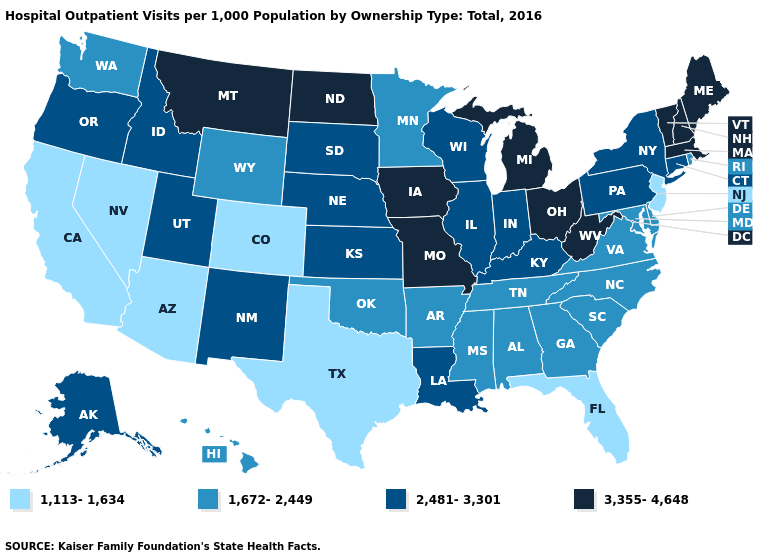Name the states that have a value in the range 2,481-3,301?
Answer briefly. Alaska, Connecticut, Idaho, Illinois, Indiana, Kansas, Kentucky, Louisiana, Nebraska, New Mexico, New York, Oregon, Pennsylvania, South Dakota, Utah, Wisconsin. What is the value of New Jersey?
Give a very brief answer. 1,113-1,634. Name the states that have a value in the range 2,481-3,301?
Keep it brief. Alaska, Connecticut, Idaho, Illinois, Indiana, Kansas, Kentucky, Louisiana, Nebraska, New Mexico, New York, Oregon, Pennsylvania, South Dakota, Utah, Wisconsin. Does the map have missing data?
Answer briefly. No. Name the states that have a value in the range 2,481-3,301?
Answer briefly. Alaska, Connecticut, Idaho, Illinois, Indiana, Kansas, Kentucky, Louisiana, Nebraska, New Mexico, New York, Oregon, Pennsylvania, South Dakota, Utah, Wisconsin. What is the highest value in states that border Tennessee?
Write a very short answer. 3,355-4,648. Name the states that have a value in the range 1,672-2,449?
Answer briefly. Alabama, Arkansas, Delaware, Georgia, Hawaii, Maryland, Minnesota, Mississippi, North Carolina, Oklahoma, Rhode Island, South Carolina, Tennessee, Virginia, Washington, Wyoming. Name the states that have a value in the range 2,481-3,301?
Give a very brief answer. Alaska, Connecticut, Idaho, Illinois, Indiana, Kansas, Kentucky, Louisiana, Nebraska, New Mexico, New York, Oregon, Pennsylvania, South Dakota, Utah, Wisconsin. Does the first symbol in the legend represent the smallest category?
Be succinct. Yes. Does Nebraska have the same value as New Mexico?
Concise answer only. Yes. What is the lowest value in states that border Delaware?
Be succinct. 1,113-1,634. Which states have the lowest value in the South?
Give a very brief answer. Florida, Texas. Does the map have missing data?
Write a very short answer. No. Name the states that have a value in the range 1,672-2,449?
Answer briefly. Alabama, Arkansas, Delaware, Georgia, Hawaii, Maryland, Minnesota, Mississippi, North Carolina, Oklahoma, Rhode Island, South Carolina, Tennessee, Virginia, Washington, Wyoming. What is the highest value in the USA?
Be succinct. 3,355-4,648. 